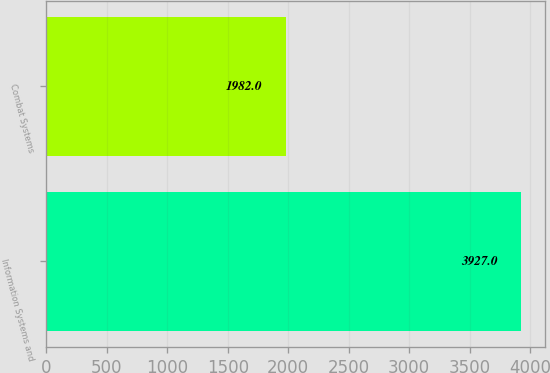Convert chart to OTSL. <chart><loc_0><loc_0><loc_500><loc_500><bar_chart><fcel>Information Systems and<fcel>Combat Systems<nl><fcel>3927<fcel>1982<nl></chart> 